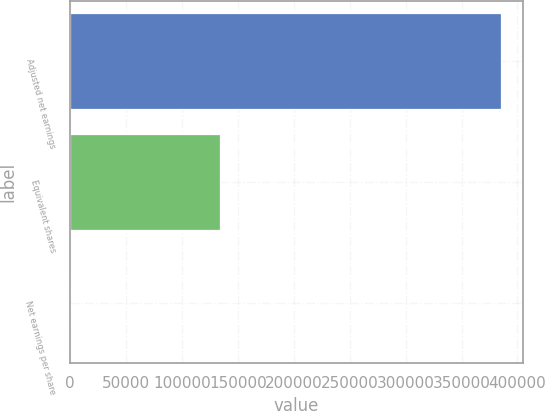Convert chart to OTSL. <chart><loc_0><loc_0><loc_500><loc_500><bar_chart><fcel>Adjusted net earnings<fcel>Equivalent shares<fcel>Net earnings per share<nl><fcel>385367<fcel>133823<fcel>2.88<nl></chart> 